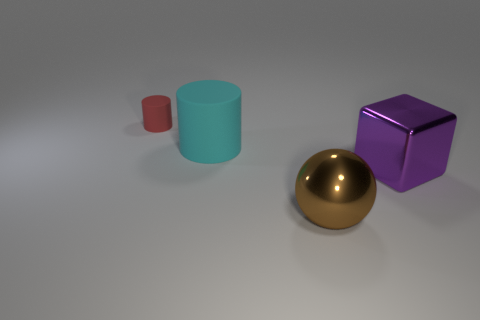The matte cylinder left of the cylinder that is in front of the cylinder that is on the left side of the big cyan thing is what color? The small cylinder to the left of the front cylinder, which is on the left side of the large cyan cylinder, is actually not red; it holds a pink hue with a matte finish. 